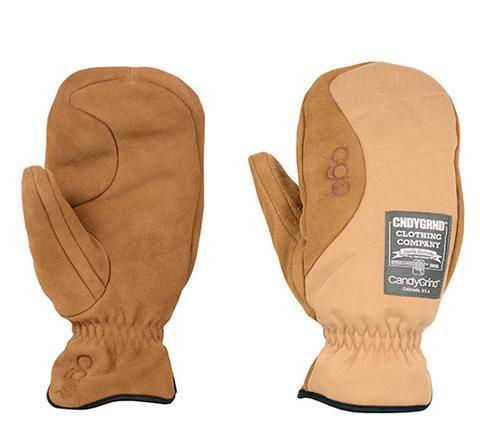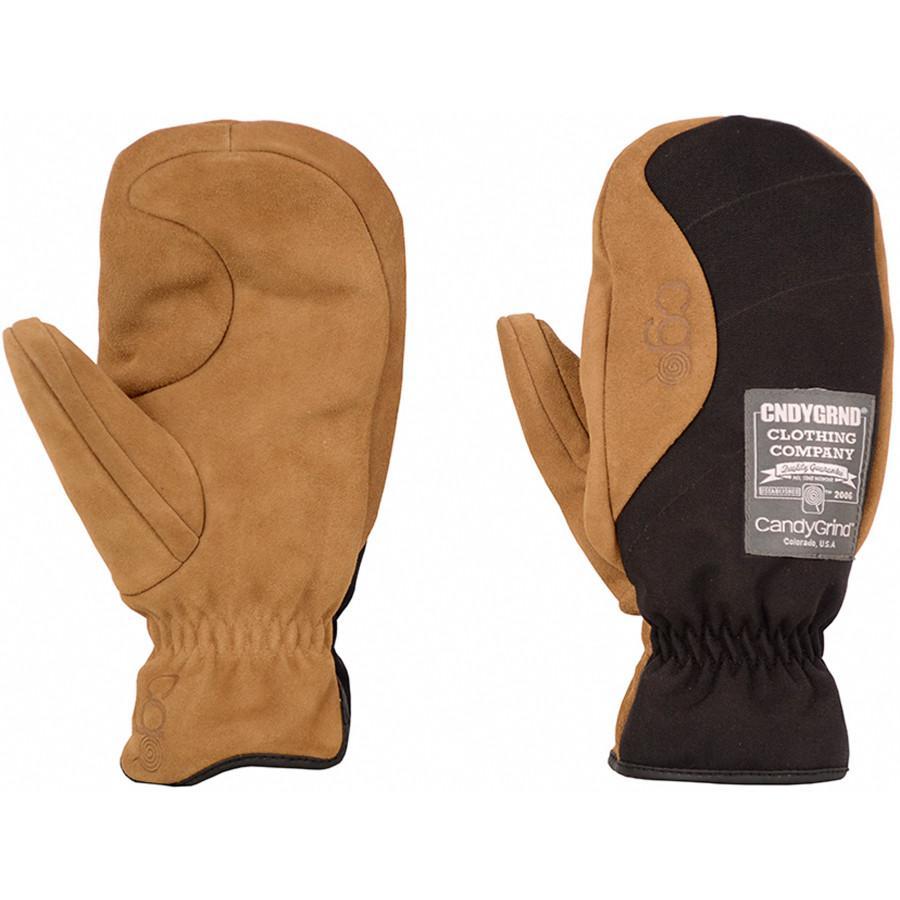The first image is the image on the left, the second image is the image on the right. For the images shown, is this caption "Two pairs of mittens are shown in front and back views, but with only one pair is one thumb section extended to the side." true? Answer yes or no. No. The first image is the image on the left, the second image is the image on the right. Analyze the images presented: Is the assertion "Each image shows the front and reverse sides of a pair of mittens, with the cuff opening at the bottom." valid? Answer yes or no. Yes. 